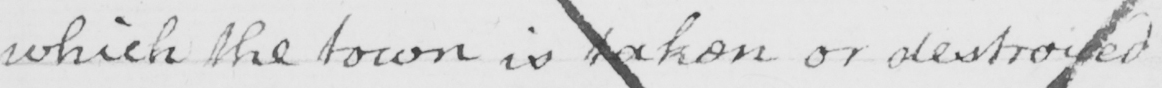What is written in this line of handwriting? which the town is taken or destroyed . 